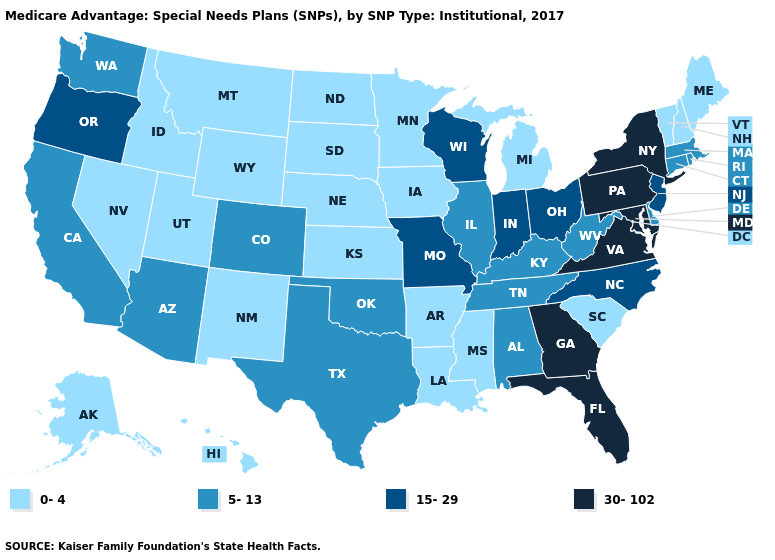What is the value of Minnesota?
Short answer required. 0-4. What is the highest value in the USA?
Be succinct. 30-102. Name the states that have a value in the range 5-13?
Give a very brief answer. Alabama, Arizona, California, Colorado, Connecticut, Delaware, Illinois, Kentucky, Massachusetts, Oklahoma, Rhode Island, Tennessee, Texas, Washington, West Virginia. Which states hav the highest value in the MidWest?
Be succinct. Indiana, Missouri, Ohio, Wisconsin. Name the states that have a value in the range 15-29?
Quick response, please. Indiana, Missouri, North Carolina, New Jersey, Ohio, Oregon, Wisconsin. What is the lowest value in states that border Florida?
Write a very short answer. 5-13. Does Alaska have the highest value in the West?
Give a very brief answer. No. Name the states that have a value in the range 5-13?
Concise answer only. Alabama, Arizona, California, Colorado, Connecticut, Delaware, Illinois, Kentucky, Massachusetts, Oklahoma, Rhode Island, Tennessee, Texas, Washington, West Virginia. What is the value of Arkansas?
Give a very brief answer. 0-4. Name the states that have a value in the range 0-4?
Be succinct. Alaska, Arkansas, Hawaii, Iowa, Idaho, Kansas, Louisiana, Maine, Michigan, Minnesota, Mississippi, Montana, North Dakota, Nebraska, New Hampshire, New Mexico, Nevada, South Carolina, South Dakota, Utah, Vermont, Wyoming. Does Iowa have the lowest value in the USA?
Write a very short answer. Yes. Is the legend a continuous bar?
Answer briefly. No. Name the states that have a value in the range 15-29?
Keep it brief. Indiana, Missouri, North Carolina, New Jersey, Ohio, Oregon, Wisconsin. What is the value of California?
Give a very brief answer. 5-13. Name the states that have a value in the range 0-4?
Short answer required. Alaska, Arkansas, Hawaii, Iowa, Idaho, Kansas, Louisiana, Maine, Michigan, Minnesota, Mississippi, Montana, North Dakota, Nebraska, New Hampshire, New Mexico, Nevada, South Carolina, South Dakota, Utah, Vermont, Wyoming. 